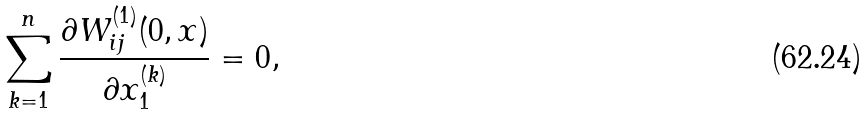Convert formula to latex. <formula><loc_0><loc_0><loc_500><loc_500>\sum _ { k = 1 } ^ { n } \frac { \partial W _ { i j } ^ { ( 1 ) } ( 0 , x ) } { \partial x _ { 1 } ^ { ( k ) } } = 0 ,</formula> 